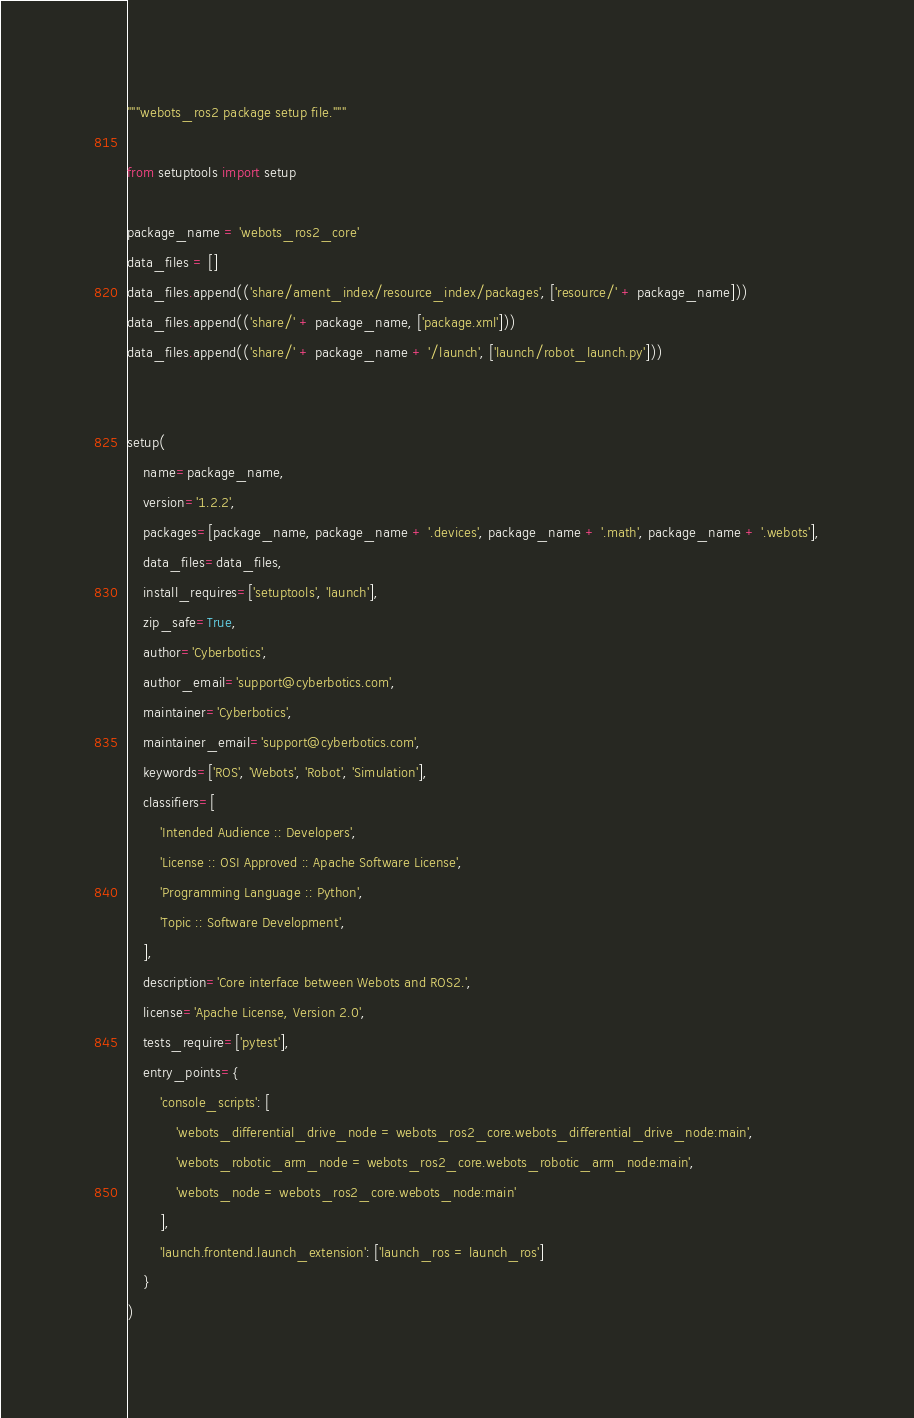Convert code to text. <code><loc_0><loc_0><loc_500><loc_500><_Python_>"""webots_ros2 package setup file."""

from setuptools import setup

package_name = 'webots_ros2_core'
data_files = []
data_files.append(('share/ament_index/resource_index/packages', ['resource/' + package_name]))
data_files.append(('share/' + package_name, ['package.xml']))
data_files.append(('share/' + package_name + '/launch', ['launch/robot_launch.py']))


setup(
    name=package_name,
    version='1.2.2',
    packages=[package_name, package_name + '.devices', package_name + '.math', package_name + '.webots'],
    data_files=data_files,
    install_requires=['setuptools', 'launch'],
    zip_safe=True,
    author='Cyberbotics',
    author_email='support@cyberbotics.com',
    maintainer='Cyberbotics',
    maintainer_email='support@cyberbotics.com',
    keywords=['ROS', 'Webots', 'Robot', 'Simulation'],
    classifiers=[
        'Intended Audience :: Developers',
        'License :: OSI Approved :: Apache Software License',
        'Programming Language :: Python',
        'Topic :: Software Development',
    ],
    description='Core interface between Webots and ROS2.',
    license='Apache License, Version 2.0',
    tests_require=['pytest'],
    entry_points={
        'console_scripts': [
            'webots_differential_drive_node = webots_ros2_core.webots_differential_drive_node:main',
            'webots_robotic_arm_node = webots_ros2_core.webots_robotic_arm_node:main',
            'webots_node = webots_ros2_core.webots_node:main'
        ],
        'launch.frontend.launch_extension': ['launch_ros = launch_ros']
    }
)
</code> 